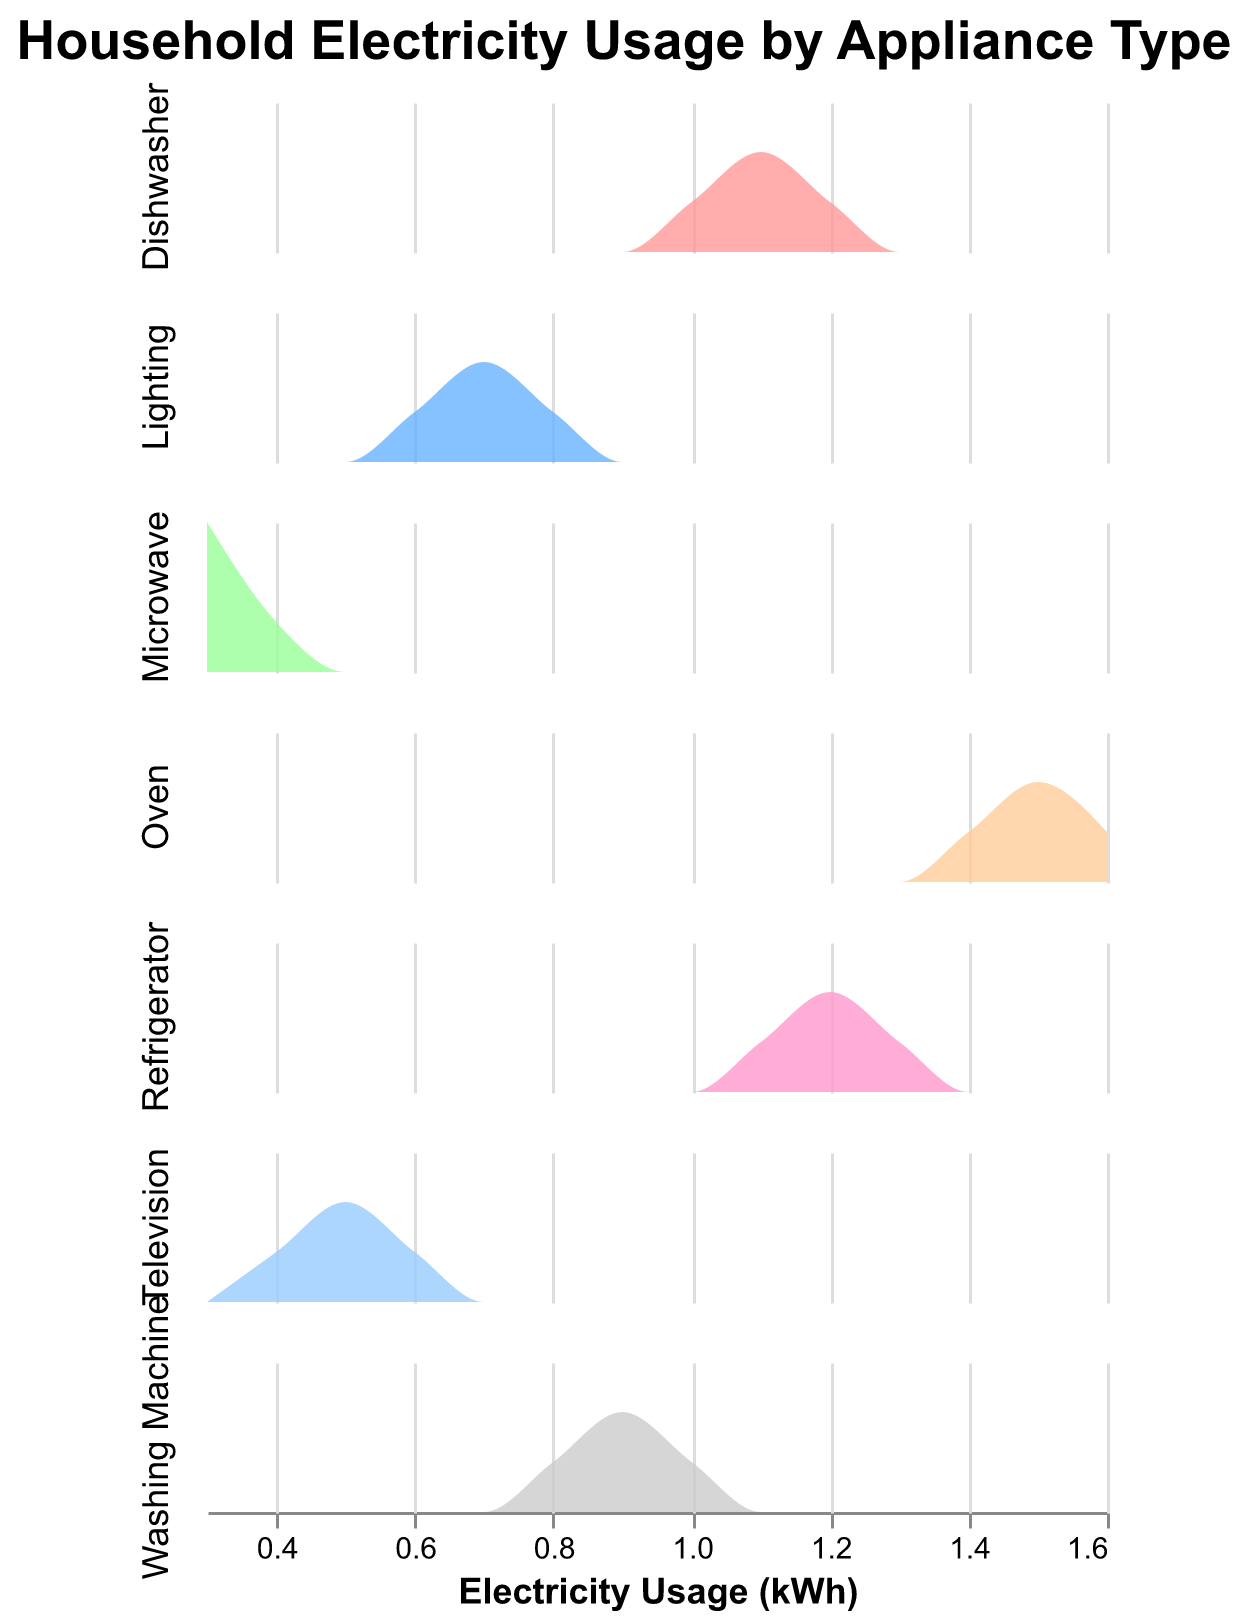What is the title of the figure? The title of the figure is displayed at the top-center and represents the main topic of the graph, which in this case is "Household Electricity Usage by Appliance Type".
Answer: Household Electricity Usage by Appliance Type How many different appliance types are included in the figure? Each row in the subplot represents a distinct appliance type. By counting the rows, we identify the number of unique appliances.
Answer: 6 Which two appliances have the highest maximum electricity usage? By inspecting each subplot representation, we identify that 'Oven' and 'Refrigerator' have the highest maximum usage, as the densities extend furthest to the right on the x-axis.
Answer: Oven and Refrigerator Is the average electricity usage by Refrigerators higher or lower than that by Televisions? To determine this, observe the center of mass of the density plots. Refrigerators are centered around 1.2 kWh, while Televisions are centered around 0.5 kWh.
Answer: Higher Which appliance has the most consistent usage pattern? The most consistent usage pattern can be identified by the narrowest and tallest density plot, indicating less variation. 'Microwave' shows this trait.
Answer: Microwave In how many kWh intervals are most Washing Machine usages clustered around? By looking at the density plot for Washing Machine, the clustering appears around 0.9 and 1.0 kWh.
Answer: 0.9 and 1.0 kWh What color represents the Oven usage in the figure? The legend or color coding for the 'Oven' density plot can be identified through its distinct appearance. It uses the color pink.
Answer: Pink Which appliance shows the lowest maximum usage? Observing the furthest right extent of each density plot, 'Microwave' shows the lowest maximum usage around 0.4 kWh.
Answer: Microwave Compare the spread of usage values for Dishwashers and Lighting. Which one has a broader spread? The broader spread is shown by the appliance whose density plot covers a larger range on the x-axis. Lighting ranges from 0.6 to 0.8 kWh, while Dishwashers range from 1.0 to 1.2 kWh. Both have similar spreads.
Answer: Similar What's the typical usage range for Lighting in the dataset? By observing the base of the density plot for Lighting, its typical range can be seen from 0.6 to 0.8 kWh.
Answer: 0.6 to 0.8 kWh 